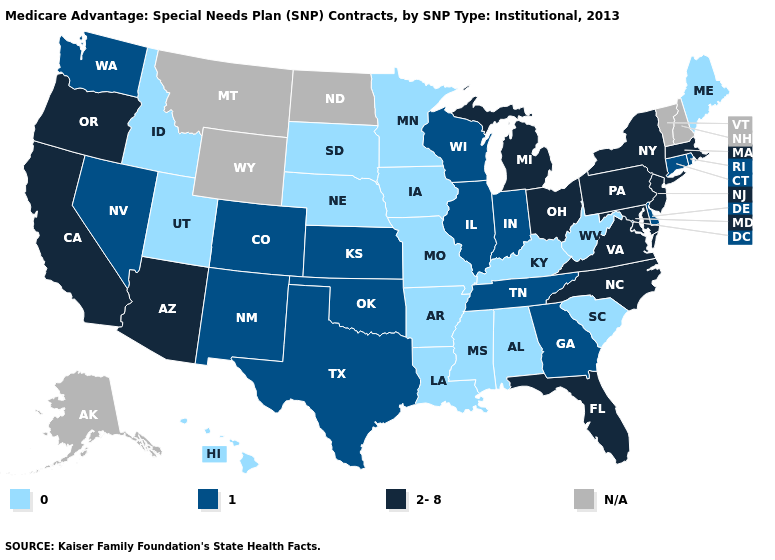What is the highest value in states that border California?
Quick response, please. 2-8. Name the states that have a value in the range N/A?
Keep it brief. Alaska, Montana, North Dakota, New Hampshire, Vermont, Wyoming. Does Florida have the lowest value in the USA?
Give a very brief answer. No. What is the value of Vermont?
Give a very brief answer. N/A. Does Michigan have the lowest value in the USA?
Keep it brief. No. Among the states that border Pennsylvania , does Ohio have the highest value?
Be succinct. Yes. Is the legend a continuous bar?
Concise answer only. No. Name the states that have a value in the range 1?
Answer briefly. Colorado, Connecticut, Delaware, Georgia, Illinois, Indiana, Kansas, New Mexico, Nevada, Oklahoma, Rhode Island, Tennessee, Texas, Washington, Wisconsin. Does Maryland have the highest value in the USA?
Be succinct. Yes. What is the lowest value in the USA?
Quick response, please. 0. Name the states that have a value in the range 2-8?
Short answer required. Arizona, California, Florida, Massachusetts, Maryland, Michigan, North Carolina, New Jersey, New York, Ohio, Oregon, Pennsylvania, Virginia. What is the value of Hawaii?
Keep it brief. 0. Does Washington have the highest value in the USA?
Quick response, please. No. 